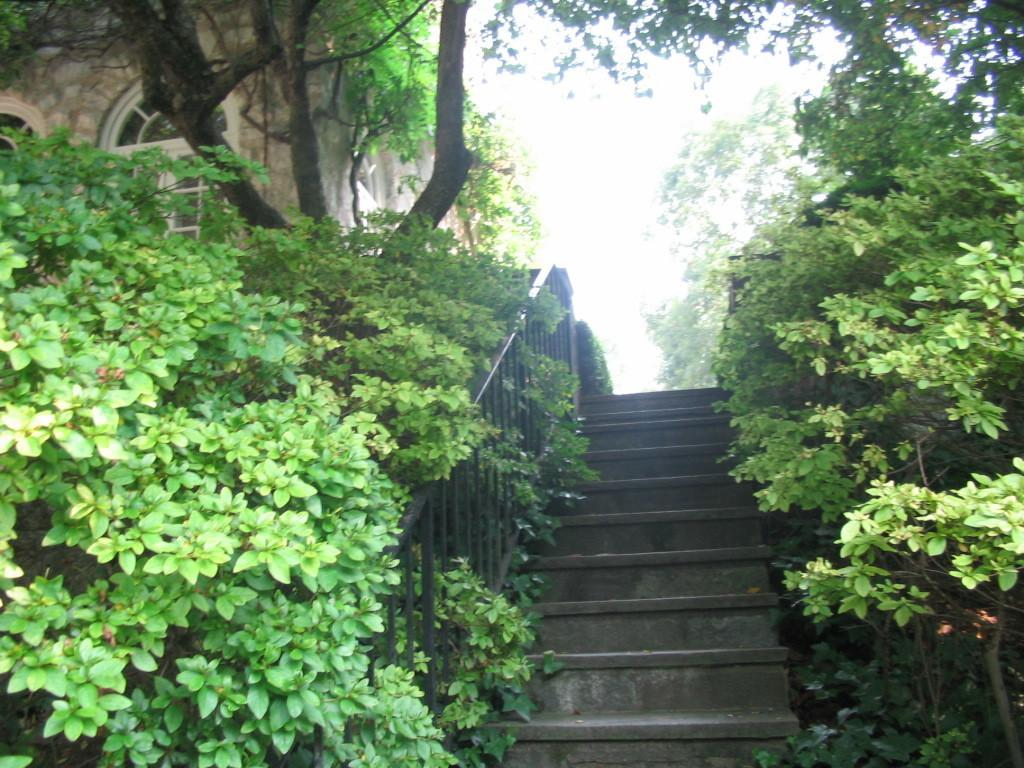What type of vegetation is present on both sides of the image? There are trees and plants on both the left and right sides of the image. What architectural feature can be seen in the middle of the image? There are steps with a railing in the middle of the image. What structure is located on the left side of the image? There is a building on the left side of the image. What is visible at the top of the image? The sky is visible at the top of the image. Can you see any cracks in the steps in the image? There is no mention of cracks in the steps in the image, so we cannot determine if any are present. Is there a chess game being played on the steps in the image? There is no indication of a chess game or any game being played in the image. How many ladybugs can be seen on the trees in the image? There is no mention of ladybugs in the image, so we cannot determine if any are present. 